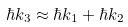Convert formula to latex. <formula><loc_0><loc_0><loc_500><loc_500>\hbar { k } _ { 3 } \approx \hbar { k } _ { 1 } + \hbar { k } _ { 2 }</formula> 